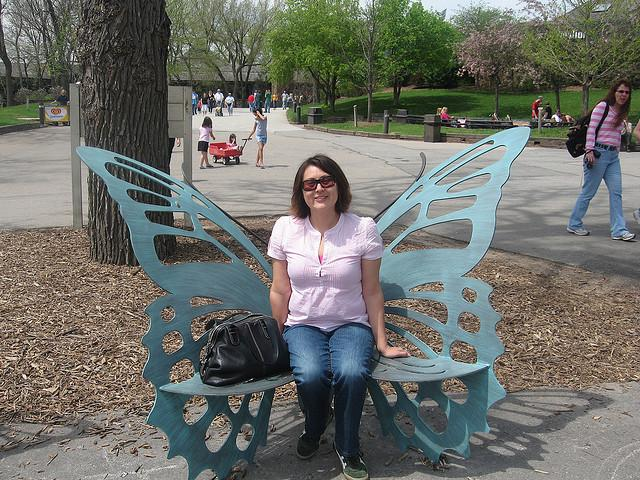What is the process that produces the type of animal depicted on the bench called? Please explain your reasoning. metamorphosis. Butterflies use this process to change from a caterpillar into a butterfly. 